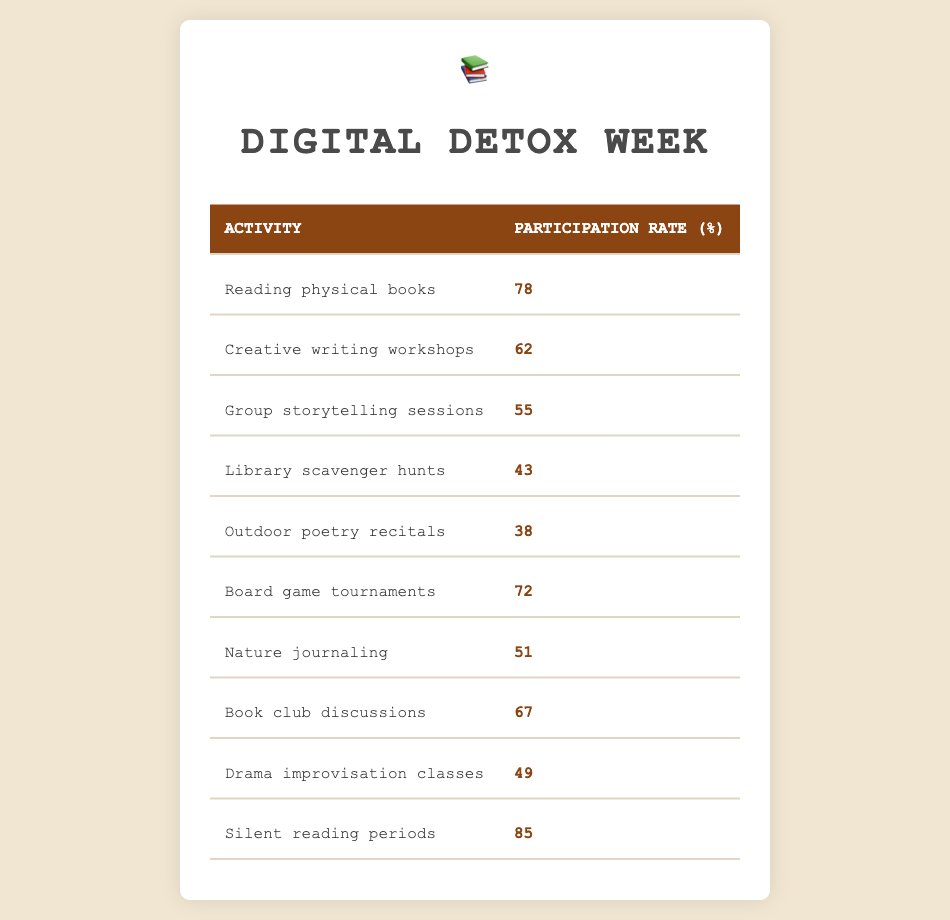What was the participation rate for reading physical books? The table lists the participation rate for reading physical books directly, which shows it is 78%.
Answer: 78% What activity had the lowest participation rate? By reviewing the participation rates, the lowest one is for outdoor poetry recitals, which is 38%.
Answer: Outdoor poetry recitals What is the participation rate for board game tournaments? The data specifically shows that the participation rate for board game tournaments is 72%.
Answer: 72% Which two activities have participation rates above 70%? Looking at the table, reading physical books (78%) and silent reading periods (85%) are the only activities above 70%.
Answer: Reading physical books and silent reading periods What is the average participation rate of all activities listed? To calculate the average, add all participation rates: 78 + 62 + 55 + 43 + 38 + 72 + 51 + 67 + 49 + 85 = 500. Then divide 500 by the number of activities (10), resulting in an average of 50%.
Answer: 50% Is the participation rate for creative writing workshops greater than the participation rate for nature journaling? The participation rate for creative writing workshops is 62%, and for nature journaling it is 51%. Since 62 is greater than 51, the answer is yes.
Answer: Yes What is the difference in participation rates between silent reading periods and group storytelling sessions? The participation rate for silent reading periods is 85% and for group storytelling sessions it is 55%. The difference is 85 - 55 = 30.
Answer: 30 Are there more activities with participation rates below 50% than those above? Reviewing the table, there are 4 activities below 50% (library scavenger hunts, outdoor poetry recitals, drama improvisation classes, and nature journaling) and 6 activities above 50%. Therefore, there are more above 50%.
Answer: No What is the total participation rate for the activities involving storytelling (both group storytelling sessions and outdoor poetry recitals)? For group storytelling sessions, the participation rate is 55%, and for outdoor poetry recitals, it is 38%. Adding these gives 55 + 38 = 93%.
Answer: 93% 